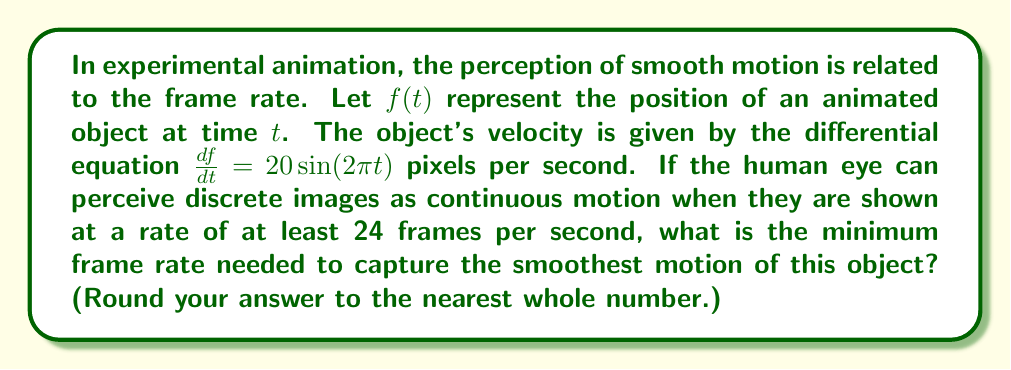Could you help me with this problem? To determine the optimal frame rate, we need to find the maximum velocity of the object and ensure that the frame rate is high enough to capture this motion smoothly.

1. The velocity of the object is given by the equation:
   $$\frac{df}{dt} = 20\sin(2\pi t)$$

2. To find the maximum velocity, we need to find the maximum value of $\sin(2\pi t)$. The sine function oscillates between -1 and 1, so the maximum value is 1.

3. Therefore, the maximum velocity is:
   $$v_{max} = 20 \cdot 1 = 20$$ pixels per second

4. For smooth motion, we need to capture the object's movement at least every pixel. This means we need a frame rate at least equal to the maximum velocity:
   $$\text{Minimum frame rate} = v_{max} = 20$$ frames per second

5. However, the question states that the human eye perceives continuous motion at a minimum of 24 frames per second. Since 20 < 24, we need to use the higher value to ensure smooth perception.

6. Therefore, the minimum frame rate needed is 24 frames per second.

7. To capture the smoothest possible motion, we should use a frame rate higher than this minimum. A common practice is to use twice the minimum rate for extra smoothness.

8. Thus, the optimal frame rate for the smoothest motion would be:
   $$\text{Optimal frame rate} = 2 \cdot 24 = 48$$ frames per second

Rounding to the nearest whole number is not necessary in this case as we already have a whole number.
Answer: 48 frames per second 